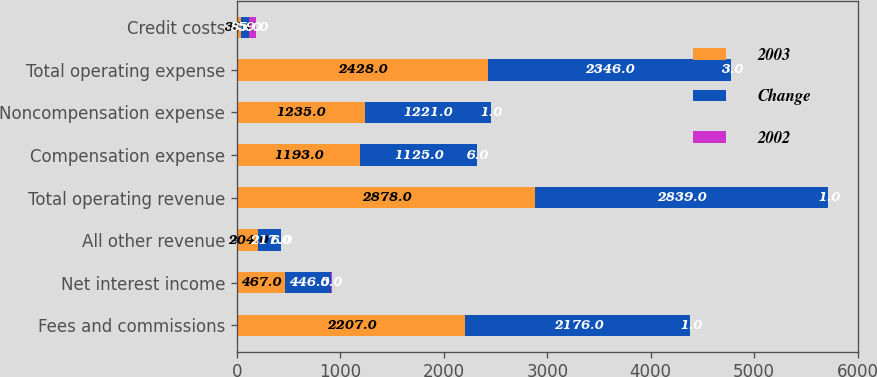<chart> <loc_0><loc_0><loc_500><loc_500><stacked_bar_chart><ecel><fcel>Fees and commissions<fcel>Net interest income<fcel>All other revenue<fcel>Total operating revenue<fcel>Compensation expense<fcel>Noncompensation expense<fcel>Total operating expense<fcel>Credit costs<nl><fcel>2003<fcel>2207<fcel>467<fcel>204<fcel>2878<fcel>1193<fcel>1235<fcel>2428<fcel>35<nl><fcel>Change<fcel>2176<fcel>446<fcel>217<fcel>2839<fcel>1125<fcel>1221<fcel>2346<fcel>85<nl><fcel>2002<fcel>1<fcel>5<fcel>6<fcel>1<fcel>6<fcel>1<fcel>3<fcel>59<nl></chart> 